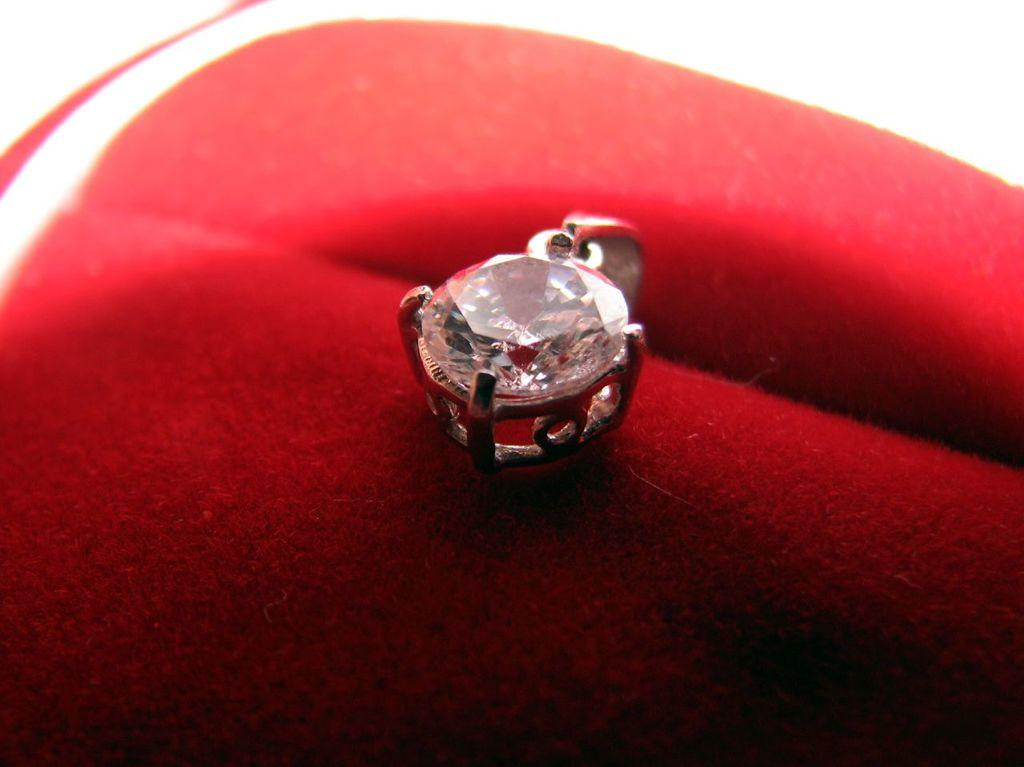What is the main subject in the center of the image? There is a pendant in the center of the image. What color is the fabric at the bottom of the image? The fabric at the bottom of the image is red. How does the snow affect the pendant in the image? There is no snow present in the image, so it cannot affect the pendant. 